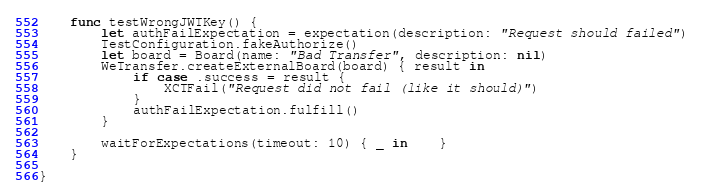Convert code to text. <code><loc_0><loc_0><loc_500><loc_500><_Swift_>	func testWrongJWTKey() {
		let authFailExpectation = expectation(description: "Request should failed")
		TestConfiguration.fakeAuthorize()
		let board = Board(name: "Bad Transfer", description: nil)
		WeTransfer.createExternalBoard(board) { result in
			if case .success = result {
				XCTFail("Request did not fail (like it should)")
			}
			authFailExpectation.fulfill()
		}
		
		waitForExpectations(timeout: 10) { _ in	}
	}

}
</code> 